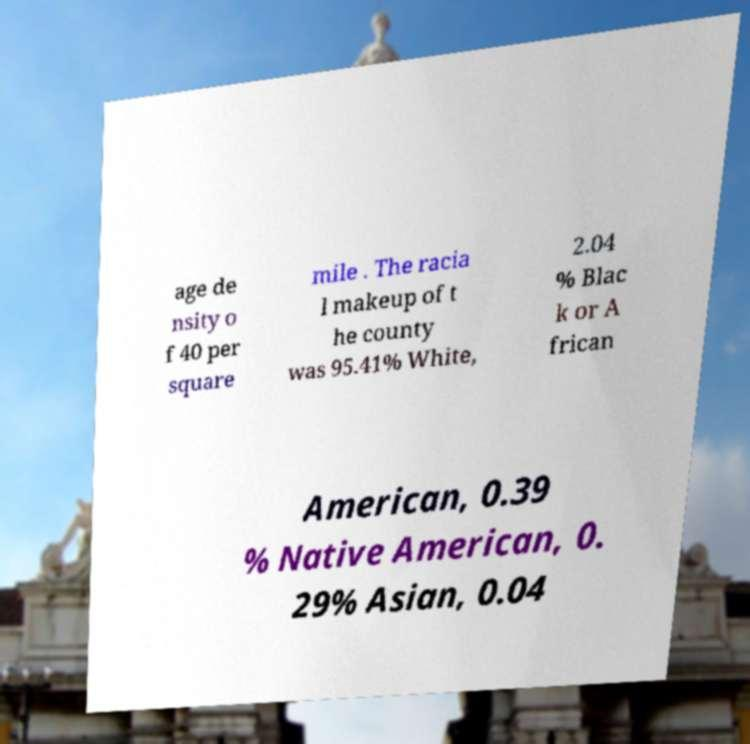For documentation purposes, I need the text within this image transcribed. Could you provide that? age de nsity o f 40 per square mile . The racia l makeup of t he county was 95.41% White, 2.04 % Blac k or A frican American, 0.39 % Native American, 0. 29% Asian, 0.04 